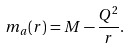Convert formula to latex. <formula><loc_0><loc_0><loc_500><loc_500>m _ { a } ( r ) = M - \frac { Q ^ { 2 } } { r } .</formula> 